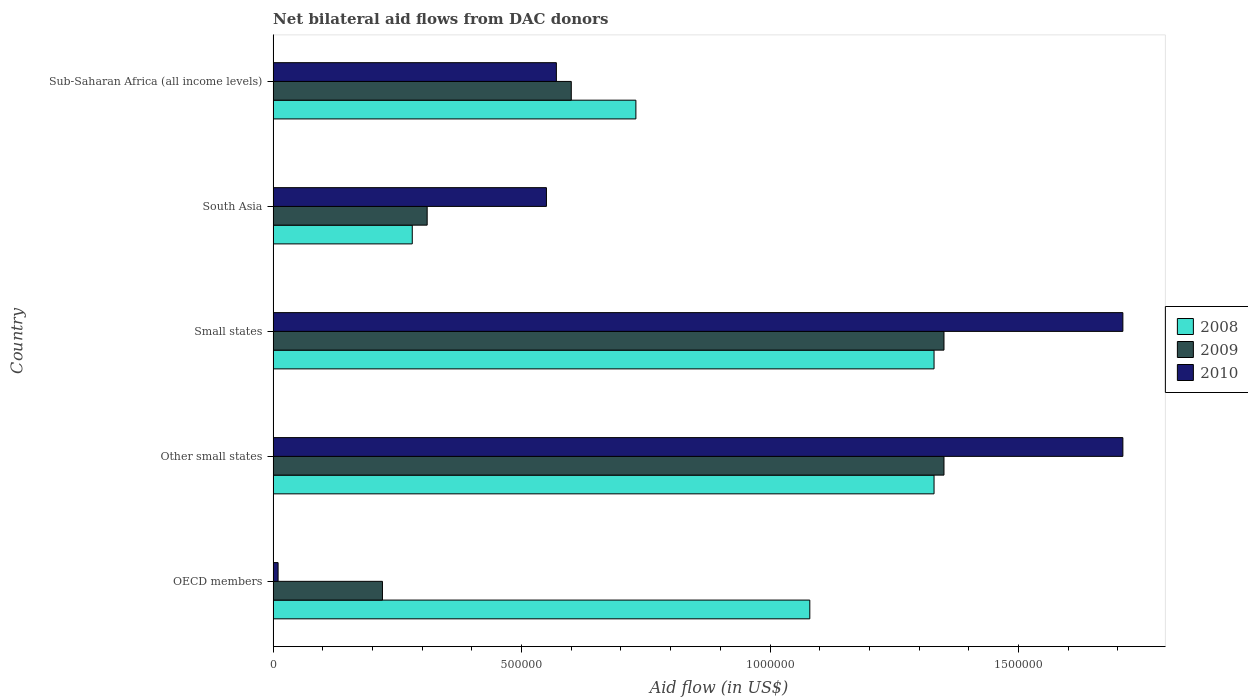How many different coloured bars are there?
Your answer should be very brief. 3. Are the number of bars on each tick of the Y-axis equal?
Give a very brief answer. Yes. What is the label of the 1st group of bars from the top?
Your response must be concise. Sub-Saharan Africa (all income levels). In how many cases, is the number of bars for a given country not equal to the number of legend labels?
Provide a short and direct response. 0. What is the net bilateral aid flow in 2010 in Small states?
Provide a short and direct response. 1.71e+06. Across all countries, what is the maximum net bilateral aid flow in 2009?
Ensure brevity in your answer.  1.35e+06. In which country was the net bilateral aid flow in 2008 maximum?
Offer a terse response. Other small states. What is the total net bilateral aid flow in 2009 in the graph?
Provide a short and direct response. 3.83e+06. What is the difference between the net bilateral aid flow in 2008 in South Asia and the net bilateral aid flow in 2010 in Sub-Saharan Africa (all income levels)?
Provide a short and direct response. -2.90e+05. What is the average net bilateral aid flow in 2010 per country?
Your answer should be compact. 9.10e+05. What is the ratio of the net bilateral aid flow in 2009 in Other small states to that in Sub-Saharan Africa (all income levels)?
Your answer should be compact. 2.25. Is the net bilateral aid flow in 2010 in Small states less than that in South Asia?
Provide a short and direct response. No. What is the difference between the highest and the lowest net bilateral aid flow in 2010?
Provide a short and direct response. 1.70e+06. Is the sum of the net bilateral aid flow in 2008 in OECD members and Sub-Saharan Africa (all income levels) greater than the maximum net bilateral aid flow in 2009 across all countries?
Your response must be concise. Yes. Is it the case that in every country, the sum of the net bilateral aid flow in 2009 and net bilateral aid flow in 2010 is greater than the net bilateral aid flow in 2008?
Your answer should be compact. No. How many bars are there?
Your response must be concise. 15. Are all the bars in the graph horizontal?
Your response must be concise. Yes. How many countries are there in the graph?
Your answer should be compact. 5. What is the difference between two consecutive major ticks on the X-axis?
Your answer should be very brief. 5.00e+05. Where does the legend appear in the graph?
Give a very brief answer. Center right. How are the legend labels stacked?
Make the answer very short. Vertical. What is the title of the graph?
Keep it short and to the point. Net bilateral aid flows from DAC donors. Does "1982" appear as one of the legend labels in the graph?
Your response must be concise. No. What is the label or title of the X-axis?
Give a very brief answer. Aid flow (in US$). What is the label or title of the Y-axis?
Offer a terse response. Country. What is the Aid flow (in US$) of 2008 in OECD members?
Ensure brevity in your answer.  1.08e+06. What is the Aid flow (in US$) of 2008 in Other small states?
Keep it short and to the point. 1.33e+06. What is the Aid flow (in US$) in 2009 in Other small states?
Keep it short and to the point. 1.35e+06. What is the Aid flow (in US$) of 2010 in Other small states?
Ensure brevity in your answer.  1.71e+06. What is the Aid flow (in US$) in 2008 in Small states?
Keep it short and to the point. 1.33e+06. What is the Aid flow (in US$) in 2009 in Small states?
Keep it short and to the point. 1.35e+06. What is the Aid flow (in US$) of 2010 in Small states?
Provide a short and direct response. 1.71e+06. What is the Aid flow (in US$) in 2010 in South Asia?
Ensure brevity in your answer.  5.50e+05. What is the Aid flow (in US$) of 2008 in Sub-Saharan Africa (all income levels)?
Ensure brevity in your answer.  7.30e+05. What is the Aid flow (in US$) in 2010 in Sub-Saharan Africa (all income levels)?
Offer a very short reply. 5.70e+05. Across all countries, what is the maximum Aid flow (in US$) in 2008?
Offer a terse response. 1.33e+06. Across all countries, what is the maximum Aid flow (in US$) of 2009?
Give a very brief answer. 1.35e+06. Across all countries, what is the maximum Aid flow (in US$) in 2010?
Your response must be concise. 1.71e+06. Across all countries, what is the minimum Aid flow (in US$) in 2010?
Give a very brief answer. 10000. What is the total Aid flow (in US$) in 2008 in the graph?
Keep it short and to the point. 4.75e+06. What is the total Aid flow (in US$) in 2009 in the graph?
Provide a short and direct response. 3.83e+06. What is the total Aid flow (in US$) of 2010 in the graph?
Your response must be concise. 4.55e+06. What is the difference between the Aid flow (in US$) in 2009 in OECD members and that in Other small states?
Your response must be concise. -1.13e+06. What is the difference between the Aid flow (in US$) in 2010 in OECD members and that in Other small states?
Offer a very short reply. -1.70e+06. What is the difference between the Aid flow (in US$) of 2008 in OECD members and that in Small states?
Keep it short and to the point. -2.50e+05. What is the difference between the Aid flow (in US$) in 2009 in OECD members and that in Small states?
Offer a very short reply. -1.13e+06. What is the difference between the Aid flow (in US$) of 2010 in OECD members and that in Small states?
Offer a very short reply. -1.70e+06. What is the difference between the Aid flow (in US$) in 2008 in OECD members and that in South Asia?
Make the answer very short. 8.00e+05. What is the difference between the Aid flow (in US$) in 2010 in OECD members and that in South Asia?
Offer a terse response. -5.40e+05. What is the difference between the Aid flow (in US$) of 2009 in OECD members and that in Sub-Saharan Africa (all income levels)?
Provide a short and direct response. -3.80e+05. What is the difference between the Aid flow (in US$) in 2010 in OECD members and that in Sub-Saharan Africa (all income levels)?
Give a very brief answer. -5.60e+05. What is the difference between the Aid flow (in US$) of 2008 in Other small states and that in South Asia?
Provide a short and direct response. 1.05e+06. What is the difference between the Aid flow (in US$) in 2009 in Other small states and that in South Asia?
Your answer should be very brief. 1.04e+06. What is the difference between the Aid flow (in US$) of 2010 in Other small states and that in South Asia?
Your answer should be compact. 1.16e+06. What is the difference between the Aid flow (in US$) in 2009 in Other small states and that in Sub-Saharan Africa (all income levels)?
Provide a short and direct response. 7.50e+05. What is the difference between the Aid flow (in US$) in 2010 in Other small states and that in Sub-Saharan Africa (all income levels)?
Provide a succinct answer. 1.14e+06. What is the difference between the Aid flow (in US$) in 2008 in Small states and that in South Asia?
Ensure brevity in your answer.  1.05e+06. What is the difference between the Aid flow (in US$) in 2009 in Small states and that in South Asia?
Your response must be concise. 1.04e+06. What is the difference between the Aid flow (in US$) in 2010 in Small states and that in South Asia?
Your answer should be compact. 1.16e+06. What is the difference between the Aid flow (in US$) of 2009 in Small states and that in Sub-Saharan Africa (all income levels)?
Offer a terse response. 7.50e+05. What is the difference between the Aid flow (in US$) in 2010 in Small states and that in Sub-Saharan Africa (all income levels)?
Your answer should be very brief. 1.14e+06. What is the difference between the Aid flow (in US$) of 2008 in South Asia and that in Sub-Saharan Africa (all income levels)?
Your answer should be compact. -4.50e+05. What is the difference between the Aid flow (in US$) in 2010 in South Asia and that in Sub-Saharan Africa (all income levels)?
Your answer should be compact. -2.00e+04. What is the difference between the Aid flow (in US$) of 2008 in OECD members and the Aid flow (in US$) of 2009 in Other small states?
Provide a short and direct response. -2.70e+05. What is the difference between the Aid flow (in US$) in 2008 in OECD members and the Aid flow (in US$) in 2010 in Other small states?
Ensure brevity in your answer.  -6.30e+05. What is the difference between the Aid flow (in US$) in 2009 in OECD members and the Aid flow (in US$) in 2010 in Other small states?
Give a very brief answer. -1.49e+06. What is the difference between the Aid flow (in US$) of 2008 in OECD members and the Aid flow (in US$) of 2009 in Small states?
Offer a very short reply. -2.70e+05. What is the difference between the Aid flow (in US$) of 2008 in OECD members and the Aid flow (in US$) of 2010 in Small states?
Give a very brief answer. -6.30e+05. What is the difference between the Aid flow (in US$) in 2009 in OECD members and the Aid flow (in US$) in 2010 in Small states?
Make the answer very short. -1.49e+06. What is the difference between the Aid flow (in US$) in 2008 in OECD members and the Aid flow (in US$) in 2009 in South Asia?
Keep it short and to the point. 7.70e+05. What is the difference between the Aid flow (in US$) in 2008 in OECD members and the Aid flow (in US$) in 2010 in South Asia?
Your response must be concise. 5.30e+05. What is the difference between the Aid flow (in US$) of 2009 in OECD members and the Aid flow (in US$) of 2010 in South Asia?
Give a very brief answer. -3.30e+05. What is the difference between the Aid flow (in US$) in 2008 in OECD members and the Aid flow (in US$) in 2010 in Sub-Saharan Africa (all income levels)?
Your response must be concise. 5.10e+05. What is the difference between the Aid flow (in US$) in 2009 in OECD members and the Aid flow (in US$) in 2010 in Sub-Saharan Africa (all income levels)?
Offer a terse response. -3.50e+05. What is the difference between the Aid flow (in US$) in 2008 in Other small states and the Aid flow (in US$) in 2009 in Small states?
Keep it short and to the point. -2.00e+04. What is the difference between the Aid flow (in US$) of 2008 in Other small states and the Aid flow (in US$) of 2010 in Small states?
Your response must be concise. -3.80e+05. What is the difference between the Aid flow (in US$) of 2009 in Other small states and the Aid flow (in US$) of 2010 in Small states?
Provide a short and direct response. -3.60e+05. What is the difference between the Aid flow (in US$) in 2008 in Other small states and the Aid flow (in US$) in 2009 in South Asia?
Provide a short and direct response. 1.02e+06. What is the difference between the Aid flow (in US$) in 2008 in Other small states and the Aid flow (in US$) in 2010 in South Asia?
Keep it short and to the point. 7.80e+05. What is the difference between the Aid flow (in US$) in 2009 in Other small states and the Aid flow (in US$) in 2010 in South Asia?
Ensure brevity in your answer.  8.00e+05. What is the difference between the Aid flow (in US$) of 2008 in Other small states and the Aid flow (in US$) of 2009 in Sub-Saharan Africa (all income levels)?
Your answer should be compact. 7.30e+05. What is the difference between the Aid flow (in US$) in 2008 in Other small states and the Aid flow (in US$) in 2010 in Sub-Saharan Africa (all income levels)?
Your answer should be compact. 7.60e+05. What is the difference between the Aid flow (in US$) of 2009 in Other small states and the Aid flow (in US$) of 2010 in Sub-Saharan Africa (all income levels)?
Your response must be concise. 7.80e+05. What is the difference between the Aid flow (in US$) in 2008 in Small states and the Aid flow (in US$) in 2009 in South Asia?
Provide a succinct answer. 1.02e+06. What is the difference between the Aid flow (in US$) of 2008 in Small states and the Aid flow (in US$) of 2010 in South Asia?
Your answer should be very brief. 7.80e+05. What is the difference between the Aid flow (in US$) in 2008 in Small states and the Aid flow (in US$) in 2009 in Sub-Saharan Africa (all income levels)?
Provide a short and direct response. 7.30e+05. What is the difference between the Aid flow (in US$) in 2008 in Small states and the Aid flow (in US$) in 2010 in Sub-Saharan Africa (all income levels)?
Keep it short and to the point. 7.60e+05. What is the difference between the Aid flow (in US$) of 2009 in Small states and the Aid flow (in US$) of 2010 in Sub-Saharan Africa (all income levels)?
Keep it short and to the point. 7.80e+05. What is the difference between the Aid flow (in US$) of 2008 in South Asia and the Aid flow (in US$) of 2009 in Sub-Saharan Africa (all income levels)?
Give a very brief answer. -3.20e+05. What is the average Aid flow (in US$) of 2008 per country?
Give a very brief answer. 9.50e+05. What is the average Aid flow (in US$) in 2009 per country?
Keep it short and to the point. 7.66e+05. What is the average Aid flow (in US$) of 2010 per country?
Ensure brevity in your answer.  9.10e+05. What is the difference between the Aid flow (in US$) in 2008 and Aid flow (in US$) in 2009 in OECD members?
Provide a succinct answer. 8.60e+05. What is the difference between the Aid flow (in US$) in 2008 and Aid flow (in US$) in 2010 in OECD members?
Offer a very short reply. 1.07e+06. What is the difference between the Aid flow (in US$) of 2008 and Aid flow (in US$) of 2009 in Other small states?
Provide a succinct answer. -2.00e+04. What is the difference between the Aid flow (in US$) of 2008 and Aid flow (in US$) of 2010 in Other small states?
Give a very brief answer. -3.80e+05. What is the difference between the Aid flow (in US$) in 2009 and Aid flow (in US$) in 2010 in Other small states?
Keep it short and to the point. -3.60e+05. What is the difference between the Aid flow (in US$) of 2008 and Aid flow (in US$) of 2010 in Small states?
Provide a short and direct response. -3.80e+05. What is the difference between the Aid flow (in US$) in 2009 and Aid flow (in US$) in 2010 in Small states?
Provide a succinct answer. -3.60e+05. What is the difference between the Aid flow (in US$) in 2008 and Aid flow (in US$) in 2009 in South Asia?
Ensure brevity in your answer.  -3.00e+04. What is the difference between the Aid flow (in US$) in 2008 and Aid flow (in US$) in 2009 in Sub-Saharan Africa (all income levels)?
Your response must be concise. 1.30e+05. What is the ratio of the Aid flow (in US$) of 2008 in OECD members to that in Other small states?
Provide a short and direct response. 0.81. What is the ratio of the Aid flow (in US$) in 2009 in OECD members to that in Other small states?
Your answer should be compact. 0.16. What is the ratio of the Aid flow (in US$) of 2010 in OECD members to that in Other small states?
Ensure brevity in your answer.  0.01. What is the ratio of the Aid flow (in US$) of 2008 in OECD members to that in Small states?
Your response must be concise. 0.81. What is the ratio of the Aid flow (in US$) in 2009 in OECD members to that in Small states?
Your response must be concise. 0.16. What is the ratio of the Aid flow (in US$) in 2010 in OECD members to that in Small states?
Your answer should be very brief. 0.01. What is the ratio of the Aid flow (in US$) of 2008 in OECD members to that in South Asia?
Your answer should be compact. 3.86. What is the ratio of the Aid flow (in US$) of 2009 in OECD members to that in South Asia?
Your response must be concise. 0.71. What is the ratio of the Aid flow (in US$) of 2010 in OECD members to that in South Asia?
Make the answer very short. 0.02. What is the ratio of the Aid flow (in US$) in 2008 in OECD members to that in Sub-Saharan Africa (all income levels)?
Offer a very short reply. 1.48. What is the ratio of the Aid flow (in US$) of 2009 in OECD members to that in Sub-Saharan Africa (all income levels)?
Your response must be concise. 0.37. What is the ratio of the Aid flow (in US$) in 2010 in OECD members to that in Sub-Saharan Africa (all income levels)?
Your answer should be compact. 0.02. What is the ratio of the Aid flow (in US$) of 2010 in Other small states to that in Small states?
Keep it short and to the point. 1. What is the ratio of the Aid flow (in US$) of 2008 in Other small states to that in South Asia?
Provide a short and direct response. 4.75. What is the ratio of the Aid flow (in US$) of 2009 in Other small states to that in South Asia?
Provide a succinct answer. 4.35. What is the ratio of the Aid flow (in US$) of 2010 in Other small states to that in South Asia?
Provide a short and direct response. 3.11. What is the ratio of the Aid flow (in US$) in 2008 in Other small states to that in Sub-Saharan Africa (all income levels)?
Provide a short and direct response. 1.82. What is the ratio of the Aid flow (in US$) of 2009 in Other small states to that in Sub-Saharan Africa (all income levels)?
Offer a very short reply. 2.25. What is the ratio of the Aid flow (in US$) of 2010 in Other small states to that in Sub-Saharan Africa (all income levels)?
Make the answer very short. 3. What is the ratio of the Aid flow (in US$) in 2008 in Small states to that in South Asia?
Keep it short and to the point. 4.75. What is the ratio of the Aid flow (in US$) of 2009 in Small states to that in South Asia?
Provide a short and direct response. 4.35. What is the ratio of the Aid flow (in US$) of 2010 in Small states to that in South Asia?
Give a very brief answer. 3.11. What is the ratio of the Aid flow (in US$) in 2008 in Small states to that in Sub-Saharan Africa (all income levels)?
Give a very brief answer. 1.82. What is the ratio of the Aid flow (in US$) of 2009 in Small states to that in Sub-Saharan Africa (all income levels)?
Provide a succinct answer. 2.25. What is the ratio of the Aid flow (in US$) in 2010 in Small states to that in Sub-Saharan Africa (all income levels)?
Ensure brevity in your answer.  3. What is the ratio of the Aid flow (in US$) in 2008 in South Asia to that in Sub-Saharan Africa (all income levels)?
Ensure brevity in your answer.  0.38. What is the ratio of the Aid flow (in US$) in 2009 in South Asia to that in Sub-Saharan Africa (all income levels)?
Provide a short and direct response. 0.52. What is the ratio of the Aid flow (in US$) in 2010 in South Asia to that in Sub-Saharan Africa (all income levels)?
Offer a terse response. 0.96. What is the difference between the highest and the second highest Aid flow (in US$) of 2010?
Make the answer very short. 0. What is the difference between the highest and the lowest Aid flow (in US$) of 2008?
Offer a terse response. 1.05e+06. What is the difference between the highest and the lowest Aid flow (in US$) in 2009?
Your answer should be compact. 1.13e+06. What is the difference between the highest and the lowest Aid flow (in US$) of 2010?
Keep it short and to the point. 1.70e+06. 